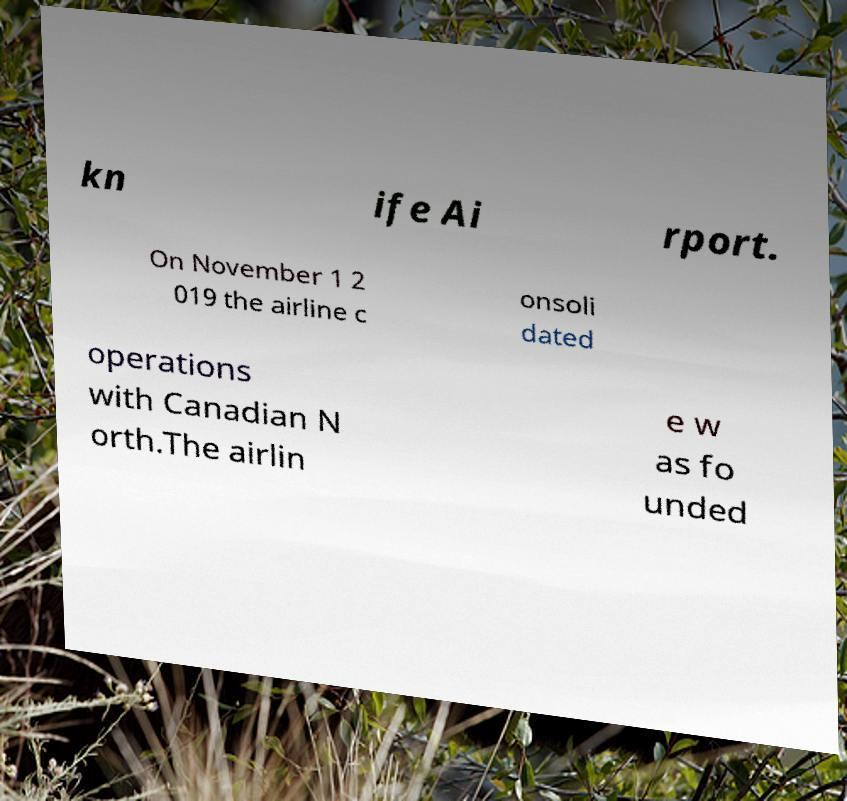There's text embedded in this image that I need extracted. Can you transcribe it verbatim? kn ife Ai rport. On November 1 2 019 the airline c onsoli dated operations with Canadian N orth.The airlin e w as fo unded 